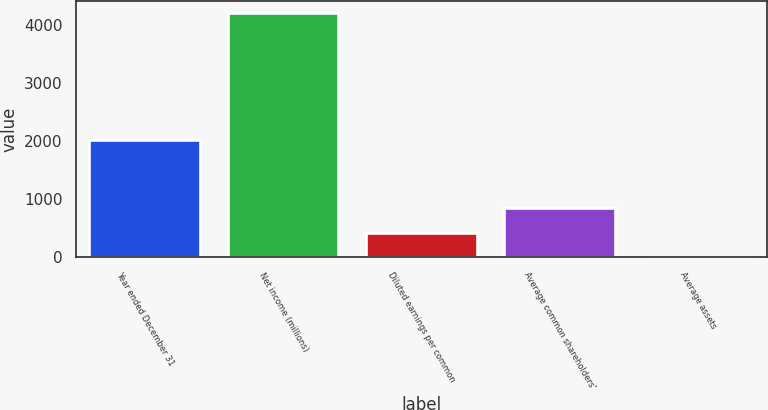<chart> <loc_0><loc_0><loc_500><loc_500><bar_chart><fcel>Year ended December 31<fcel>Net income (millions)<fcel>Diluted earnings per common<fcel>Average common shareholders'<fcel>Average assets<nl><fcel>2014<fcel>4207<fcel>421.85<fcel>842.42<fcel>1.28<nl></chart> 